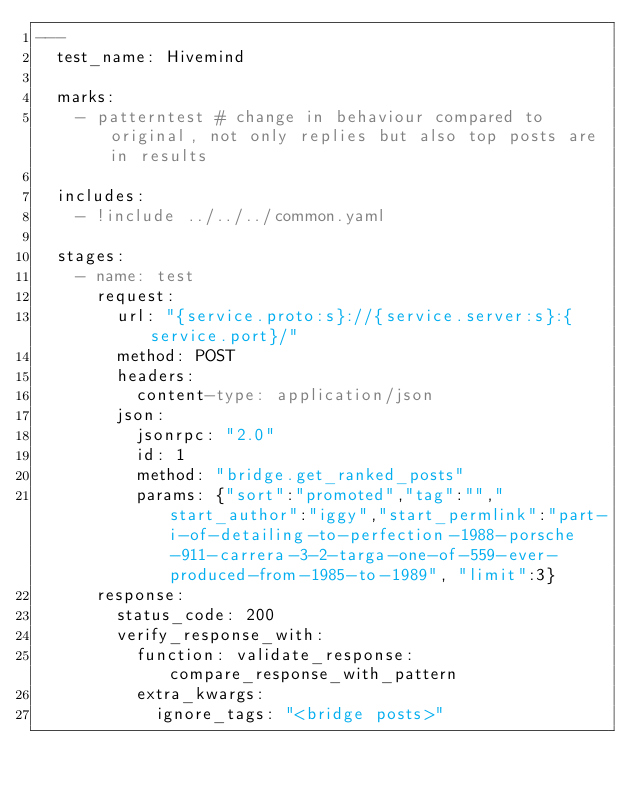<code> <loc_0><loc_0><loc_500><loc_500><_YAML_>---
  test_name: Hivemind

  marks:
    - patterntest # change in behaviour compared to original, not only replies but also top posts are in results

  includes:
    - !include ../../../common.yaml

  stages:
    - name: test
      request:
        url: "{service.proto:s}://{service.server:s}:{service.port}/"
        method: POST
        headers:
          content-type: application/json
        json:
          jsonrpc: "2.0"
          id: 1
          method: "bridge.get_ranked_posts"
          params: {"sort":"promoted","tag":"","start_author":"iggy","start_permlink":"part-i-of-detailing-to-perfection-1988-porsche-911-carrera-3-2-targa-one-of-559-ever-produced-from-1985-to-1989", "limit":3}
      response:
        status_code: 200
        verify_response_with:
          function: validate_response:compare_response_with_pattern
          extra_kwargs:
            ignore_tags: "<bridge posts>"
</code> 